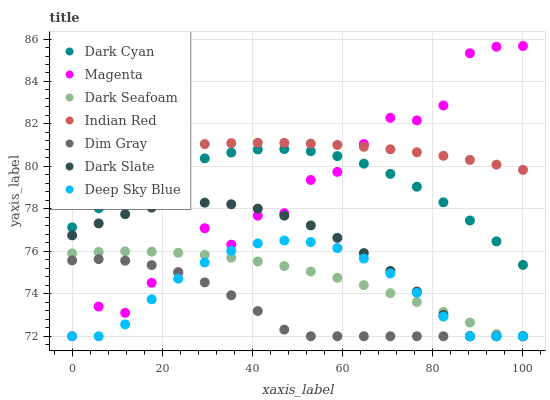Does Dim Gray have the minimum area under the curve?
Answer yes or no. Yes. Does Indian Red have the maximum area under the curve?
Answer yes or no. Yes. Does Deep Sky Blue have the minimum area under the curve?
Answer yes or no. No. Does Deep Sky Blue have the maximum area under the curve?
Answer yes or no. No. Is Indian Red the smoothest?
Answer yes or no. Yes. Is Magenta the roughest?
Answer yes or no. Yes. Is Deep Sky Blue the smoothest?
Answer yes or no. No. Is Deep Sky Blue the roughest?
Answer yes or no. No. Does Dim Gray have the lowest value?
Answer yes or no. Yes. Does Indian Red have the lowest value?
Answer yes or no. No. Does Magenta have the highest value?
Answer yes or no. Yes. Does Deep Sky Blue have the highest value?
Answer yes or no. No. Is Dark Slate less than Dark Cyan?
Answer yes or no. Yes. Is Indian Red greater than Dark Slate?
Answer yes or no. Yes. Does Deep Sky Blue intersect Dim Gray?
Answer yes or no. Yes. Is Deep Sky Blue less than Dim Gray?
Answer yes or no. No. Is Deep Sky Blue greater than Dim Gray?
Answer yes or no. No. Does Dark Slate intersect Dark Cyan?
Answer yes or no. No. 